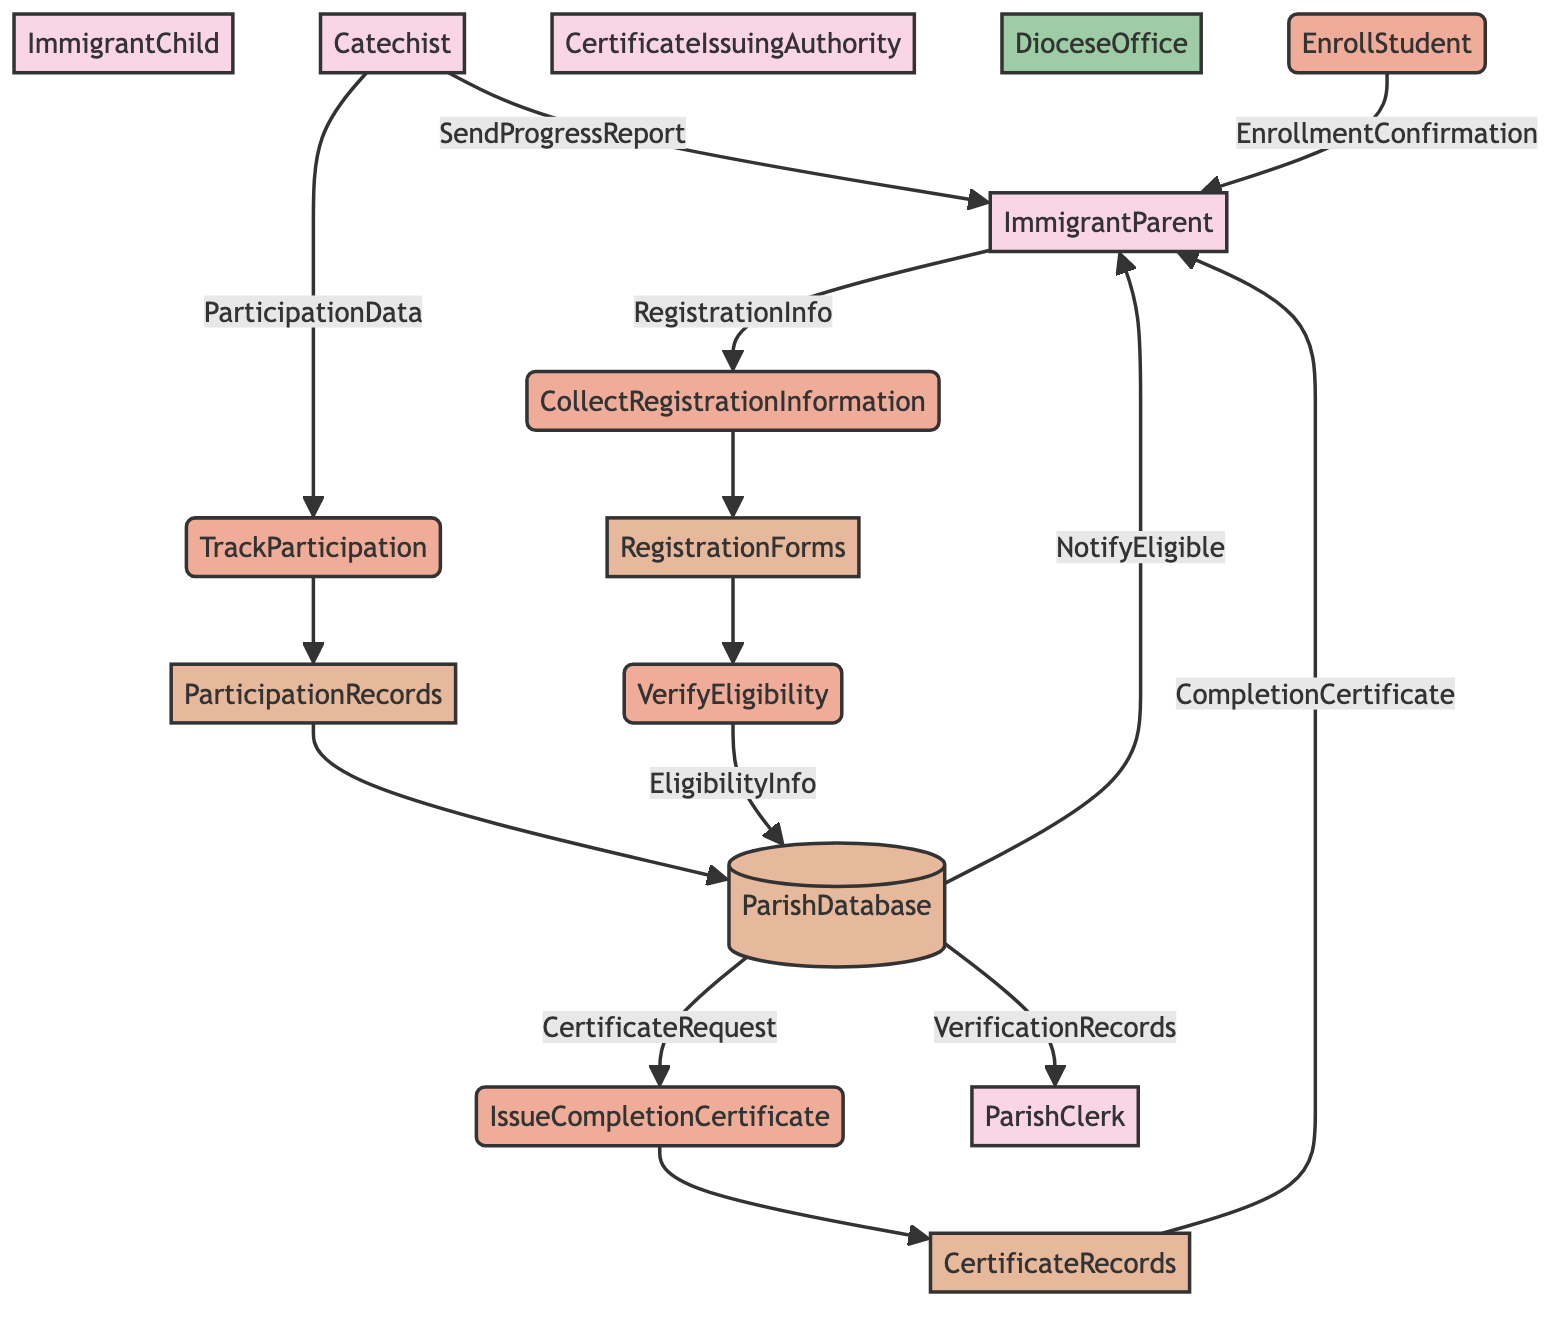What is the role of the ParishClerk? The ParishClerk is responsible for collecting registration information, verifying eligibility, and enrolling the immigrant child in the ParishDatabase.
Answer: handling registrations and records How many data stores are present in the diagram? The data stores represented are RegistrationForms, ParticipationRecords, and CertificateRecords, totaling to three data stores.
Answer: 3 What type of information does the flow named "CompletionCertificate" convey? The "CompletionCertificate" flow conveys information about the certificate issued by the CertificateIssuingAuthority to the ImmigrantParent.
Answer: completion certificate Who is responsible for tracking the participation of the immigrant child? The Catechist is responsible for tracking the participation and progress of the immigrant child in religious education classes.
Answer: Catechist What process comes after collecting registration information? After collecting registration information, the next process is verifying the eligibility of the immigrant child for enrollment.
Answer: VerifyEligibility Which entity receives the notification confirming eligibility? The ImmigrantParent receives the notification confirming eligibility after the ParishDatabase verifies it.
Answer: ImmigrantParent What does the flow "SendProgressReport" represent? The flow "SendProgressReport" represents a message from the Catechist to the ImmigrantParent updating them on the child's progress.
Answer: message What step is taken before issuing a completion certificate? Before issuing a completion certificate, a certificate request is sent from the ParishDatabase to the CertificateIssuingAuthority.
Answer: certificate request Which external entity oversees the religious education programs? The DioceseOffice is the external entity that oversees the religious education programs.
Answer: DioceseOffice 